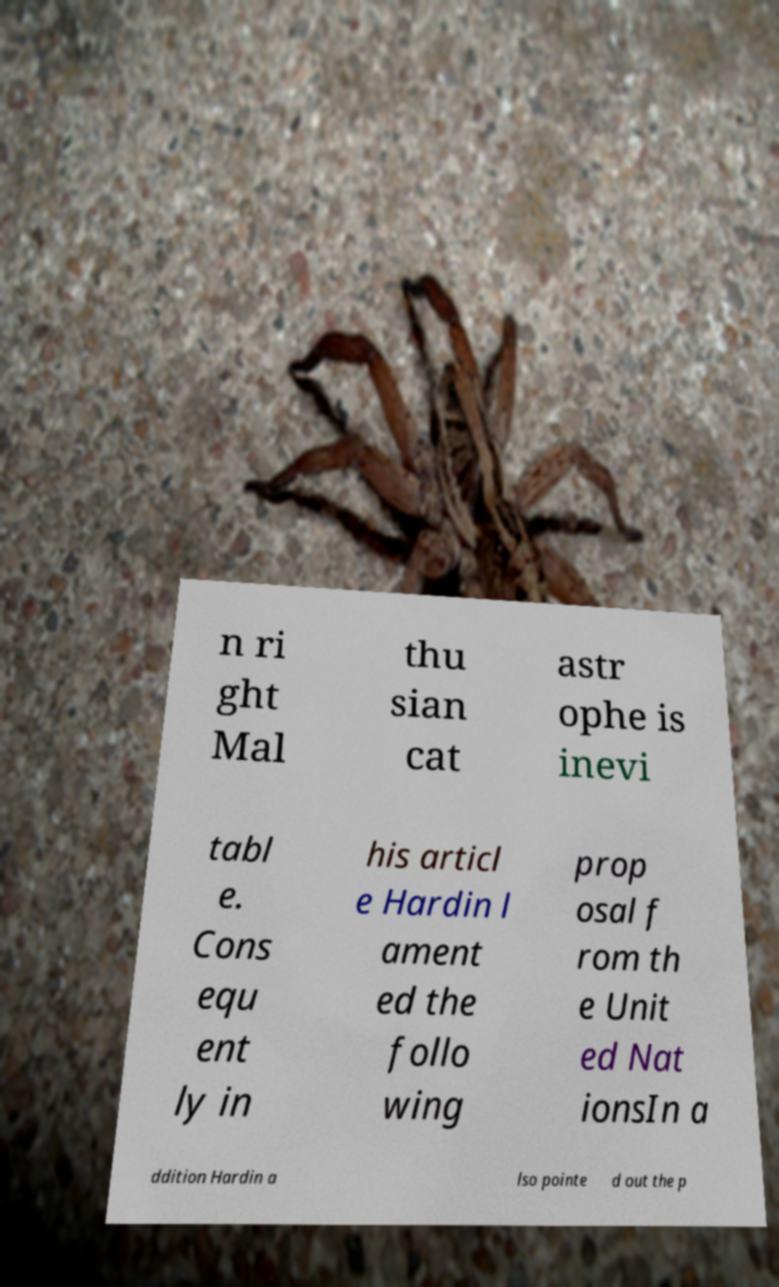Can you accurately transcribe the text from the provided image for me? n ri ght Mal thu sian cat astr ophe is inevi tabl e. Cons equ ent ly in his articl e Hardin l ament ed the follo wing prop osal f rom th e Unit ed Nat ionsIn a ddition Hardin a lso pointe d out the p 